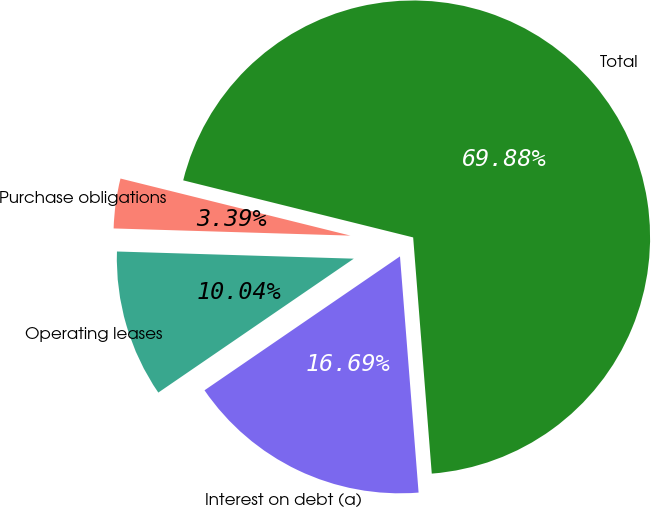Convert chart. <chart><loc_0><loc_0><loc_500><loc_500><pie_chart><fcel>Interest on debt (a)<fcel>Operating leases<fcel>Purchase obligations<fcel>Total<nl><fcel>16.69%<fcel>10.04%<fcel>3.39%<fcel>69.87%<nl></chart> 